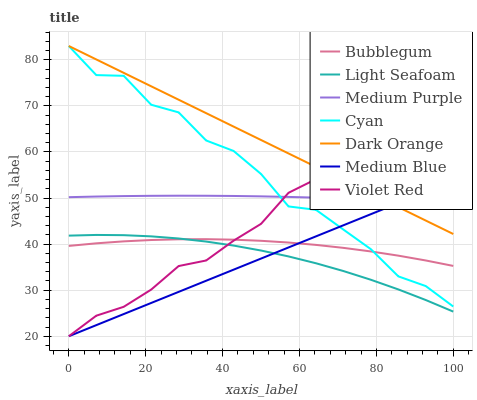Does Medium Blue have the minimum area under the curve?
Answer yes or no. Yes. Does Dark Orange have the maximum area under the curve?
Answer yes or no. Yes. Does Violet Red have the minimum area under the curve?
Answer yes or no. No. Does Violet Red have the maximum area under the curve?
Answer yes or no. No. Is Medium Blue the smoothest?
Answer yes or no. Yes. Is Cyan the roughest?
Answer yes or no. Yes. Is Violet Red the smoothest?
Answer yes or no. No. Is Violet Red the roughest?
Answer yes or no. No. Does Bubblegum have the lowest value?
Answer yes or no. No. Does Violet Red have the highest value?
Answer yes or no. No. Is Light Seafoam less than Cyan?
Answer yes or no. Yes. Is Medium Purple greater than Light Seafoam?
Answer yes or no. Yes. Does Light Seafoam intersect Cyan?
Answer yes or no. No. 